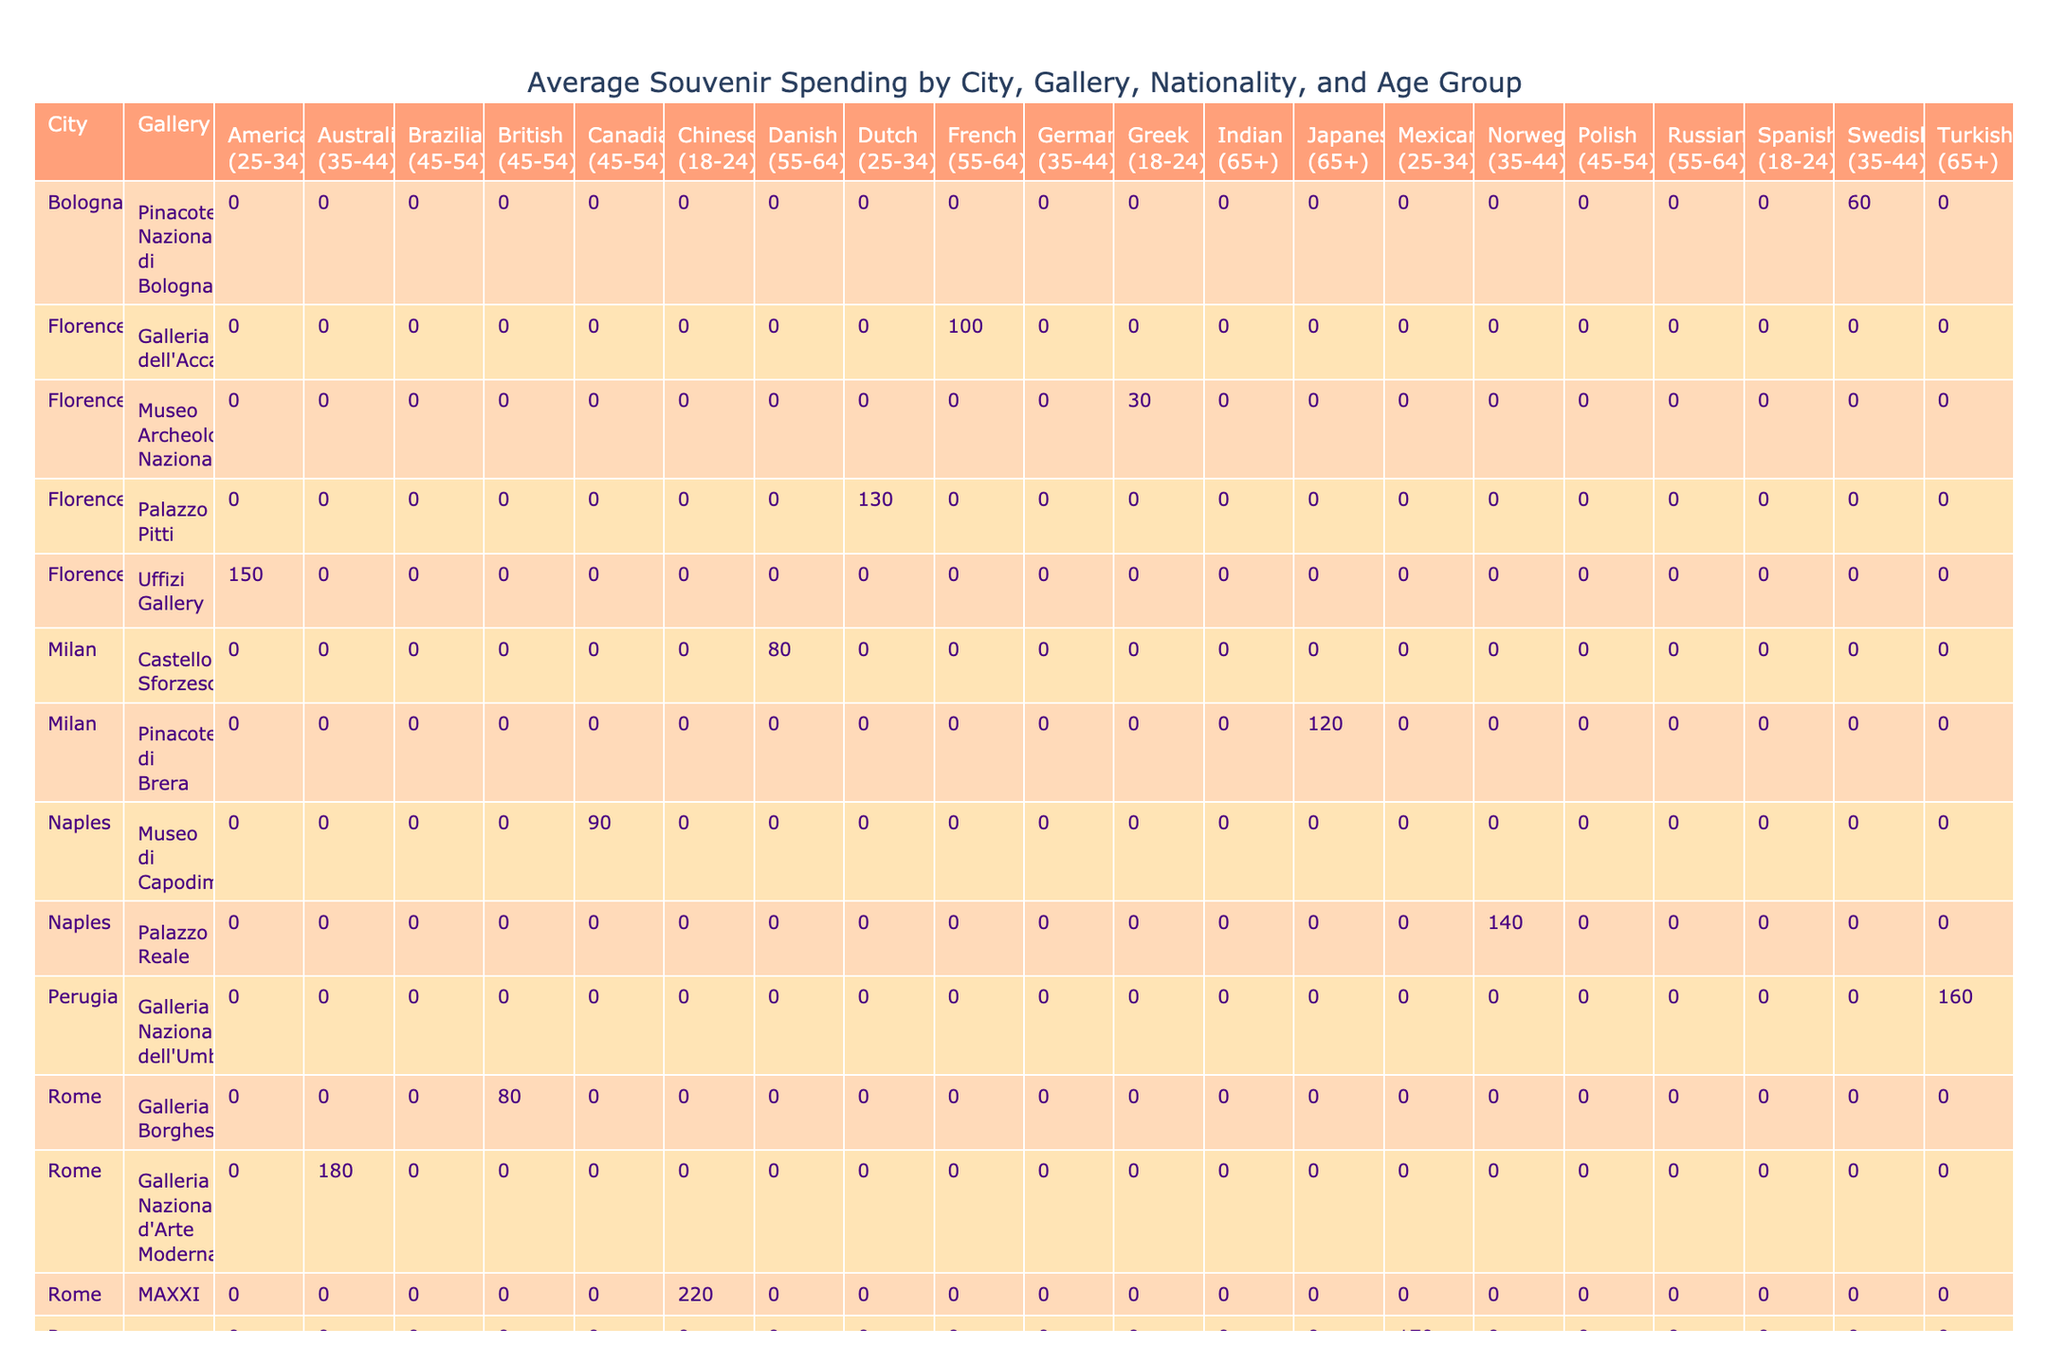What is the average spending on souvenirs for American visitors aged 25-34 in Florence? In the table, there is only one entry for American visitors aged 25-34 in Florence at the Uffizi Gallery, and their spending on souvenirs is 150. Since there's no averaging needed with a single entry, the answer is simply the spending listed.
Answer: 150 Which city has the highest average souvenir spending for British visitors aged 45-54? The table shows one entry for British visitors aged 45-54, which is in Rome at the Galleria Borghese with a spending of 80. Since there's only one data point, it is also the highest by default.
Answer: 80 Is there any visitor group that spent less than 50 on souvenirs in any gallery? Reviewing the table, the only entry that mentions spending less than 50 is the Spanish visitors aged 18-24 at the Vatican Museums, with 50 being the exact figure. Therefore, there are no groups spending less than 50.
Answer: No What is the combined spending on souvenirs for all visitors aged 35-44 across all cities? To find the total spending for visitors aged 35-44, we add the spending from each relevant row: 200 (German) + 180 (Australian) + 60 (Swedish) + 140 (Norwegian) = 580. Therefore, the combined spending for this age group is 580.
Answer: 580 Which nationality has the highest spending on souvenirs in Italian galleries? By checking the table, we calculate the highest spending: American (150) + British (80) + German (200) + Australian (180) + Canadian (90) + Brazilian (110) + Japanese (120) + Dutch (130) + Indian (40) + Turkish (160) = 200 for German visitors. Thus, Germans exhibit the highest individual spending.
Answer: German 